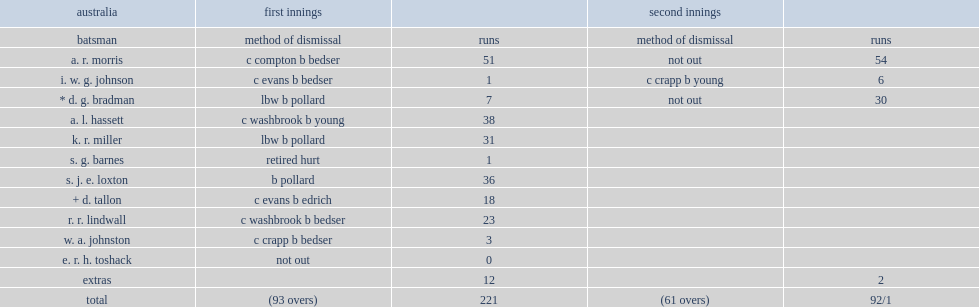How many runs were australia thus bowled out for? 221.0. 